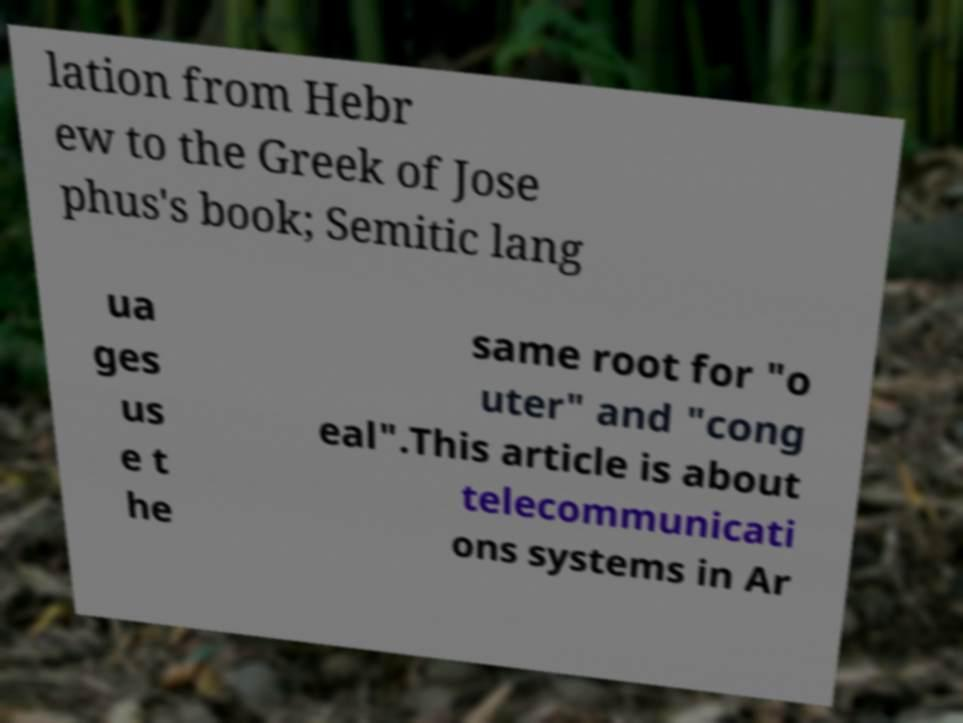For documentation purposes, I need the text within this image transcribed. Could you provide that? lation from Hebr ew to the Greek of Jose phus's book; Semitic lang ua ges us e t he same root for "o uter" and "cong eal".This article is about telecommunicati ons systems in Ar 